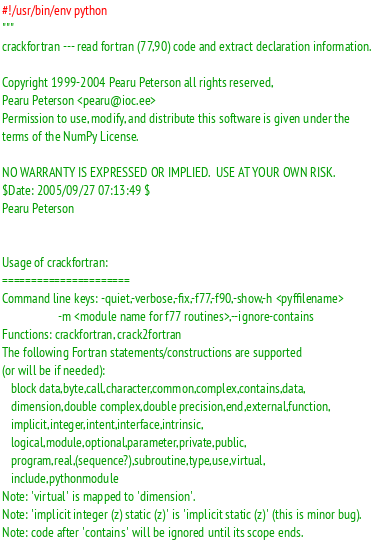<code> <loc_0><loc_0><loc_500><loc_500><_Python_>#!/usr/bin/env python
"""
crackfortran --- read fortran (77,90) code and extract declaration information.

Copyright 1999-2004 Pearu Peterson all rights reserved,
Pearu Peterson <pearu@ioc.ee>
Permission to use, modify, and distribute this software is given under the
terms of the NumPy License.

NO WARRANTY IS EXPRESSED OR IMPLIED.  USE AT YOUR OWN RISK.
$Date: 2005/09/27 07:13:49 $
Pearu Peterson


Usage of crackfortran:
======================
Command line keys: -quiet,-verbose,-fix,-f77,-f90,-show,-h <pyffilename>
                   -m <module name for f77 routines>,--ignore-contains
Functions: crackfortran, crack2fortran
The following Fortran statements/constructions are supported
(or will be if needed):
   block data,byte,call,character,common,complex,contains,data,
   dimension,double complex,double precision,end,external,function,
   implicit,integer,intent,interface,intrinsic,
   logical,module,optional,parameter,private,public,
   program,real,(sequence?),subroutine,type,use,virtual,
   include,pythonmodule
Note: 'virtual' is mapped to 'dimension'.
Note: 'implicit integer (z) static (z)' is 'implicit static (z)' (this is minor bug).
Note: code after 'contains' will be ignored until its scope ends.</code> 